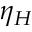Convert formula to latex. <formula><loc_0><loc_0><loc_500><loc_500>\eta _ { H }</formula> 